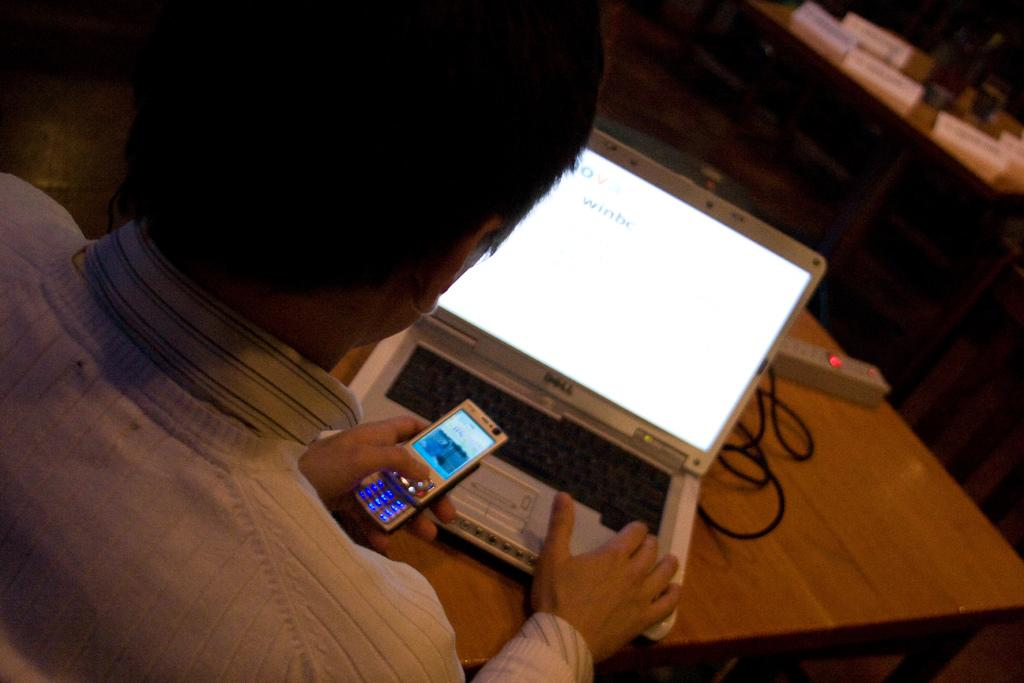<image>
Provide a brief description of the given image. A man holds a phone in front of a laptop that says winbc on the screen. 